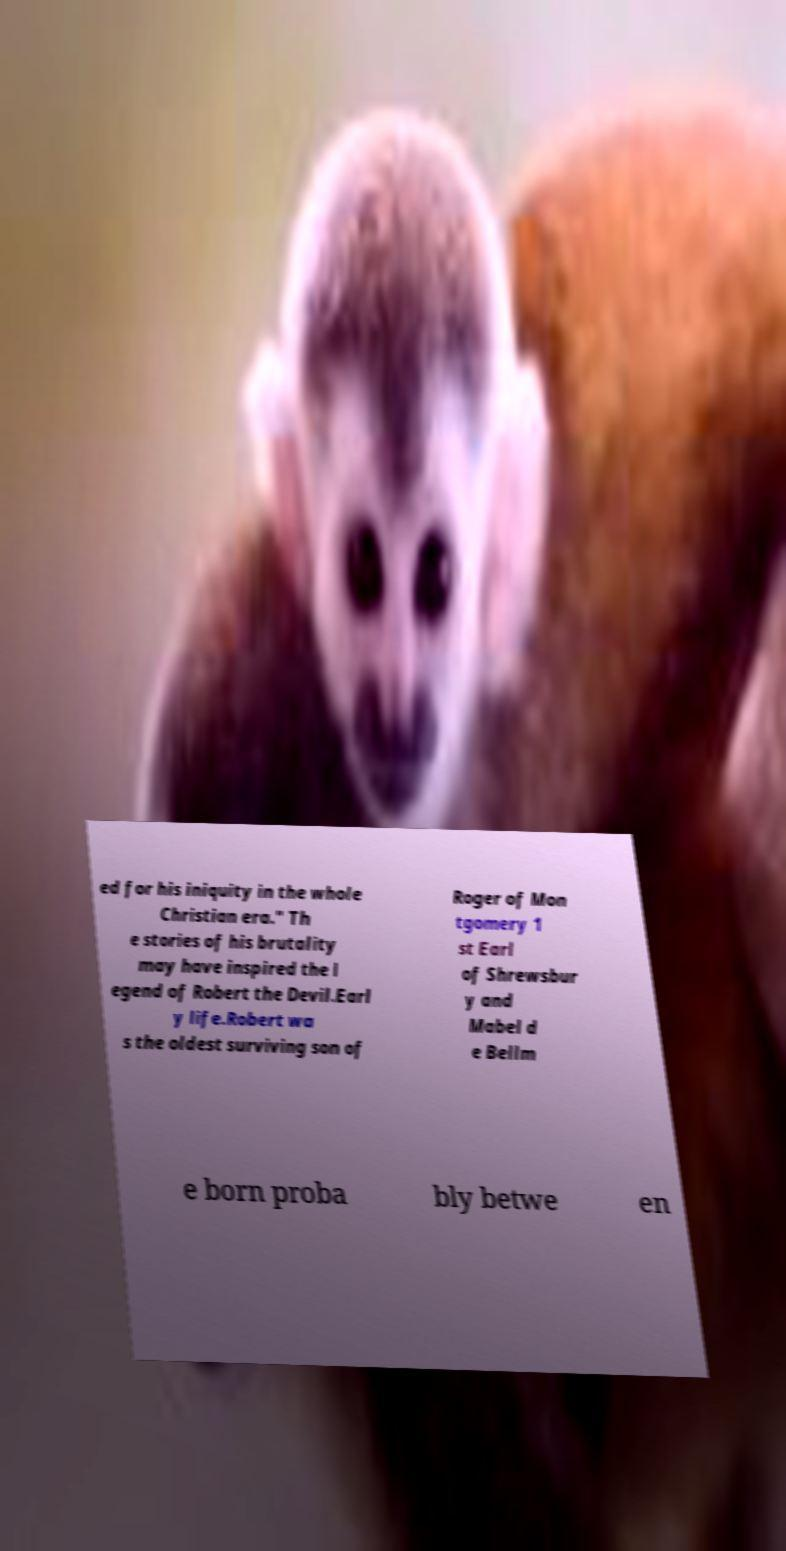Can you read and provide the text displayed in the image?This photo seems to have some interesting text. Can you extract and type it out for me? ed for his iniquity in the whole Christian era." Th e stories of his brutality may have inspired the l egend of Robert the Devil.Earl y life.Robert wa s the oldest surviving son of Roger of Mon tgomery 1 st Earl of Shrewsbur y and Mabel d e Bellm e born proba bly betwe en 